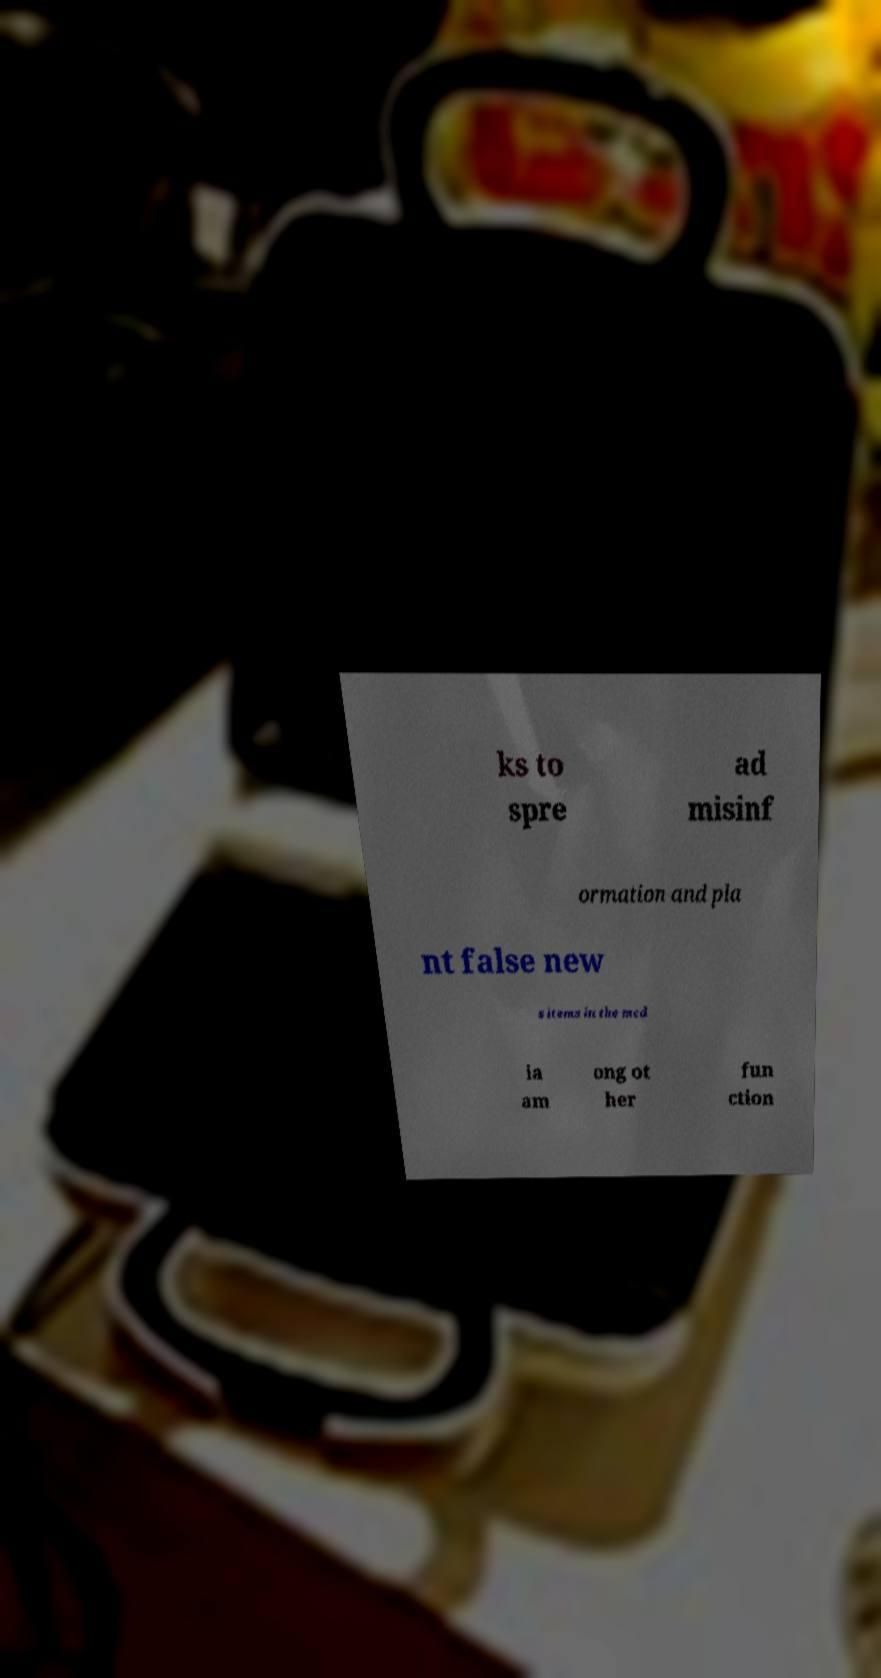For documentation purposes, I need the text within this image transcribed. Could you provide that? ks to spre ad misinf ormation and pla nt false new s items in the med ia am ong ot her fun ction 